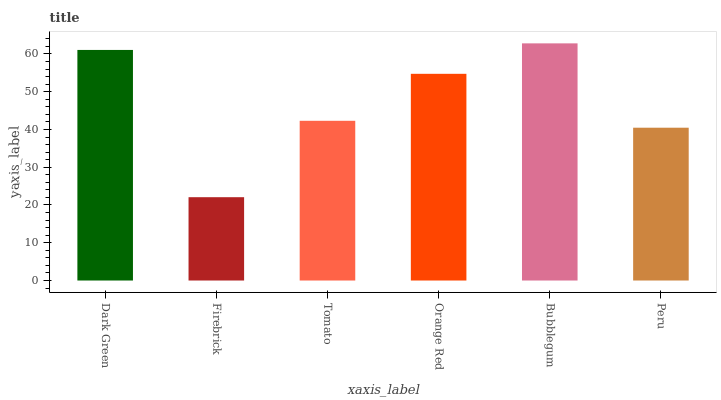Is Tomato the minimum?
Answer yes or no. No. Is Tomato the maximum?
Answer yes or no. No. Is Tomato greater than Firebrick?
Answer yes or no. Yes. Is Firebrick less than Tomato?
Answer yes or no. Yes. Is Firebrick greater than Tomato?
Answer yes or no. No. Is Tomato less than Firebrick?
Answer yes or no. No. Is Orange Red the high median?
Answer yes or no. Yes. Is Tomato the low median?
Answer yes or no. Yes. Is Peru the high median?
Answer yes or no. No. Is Orange Red the low median?
Answer yes or no. No. 